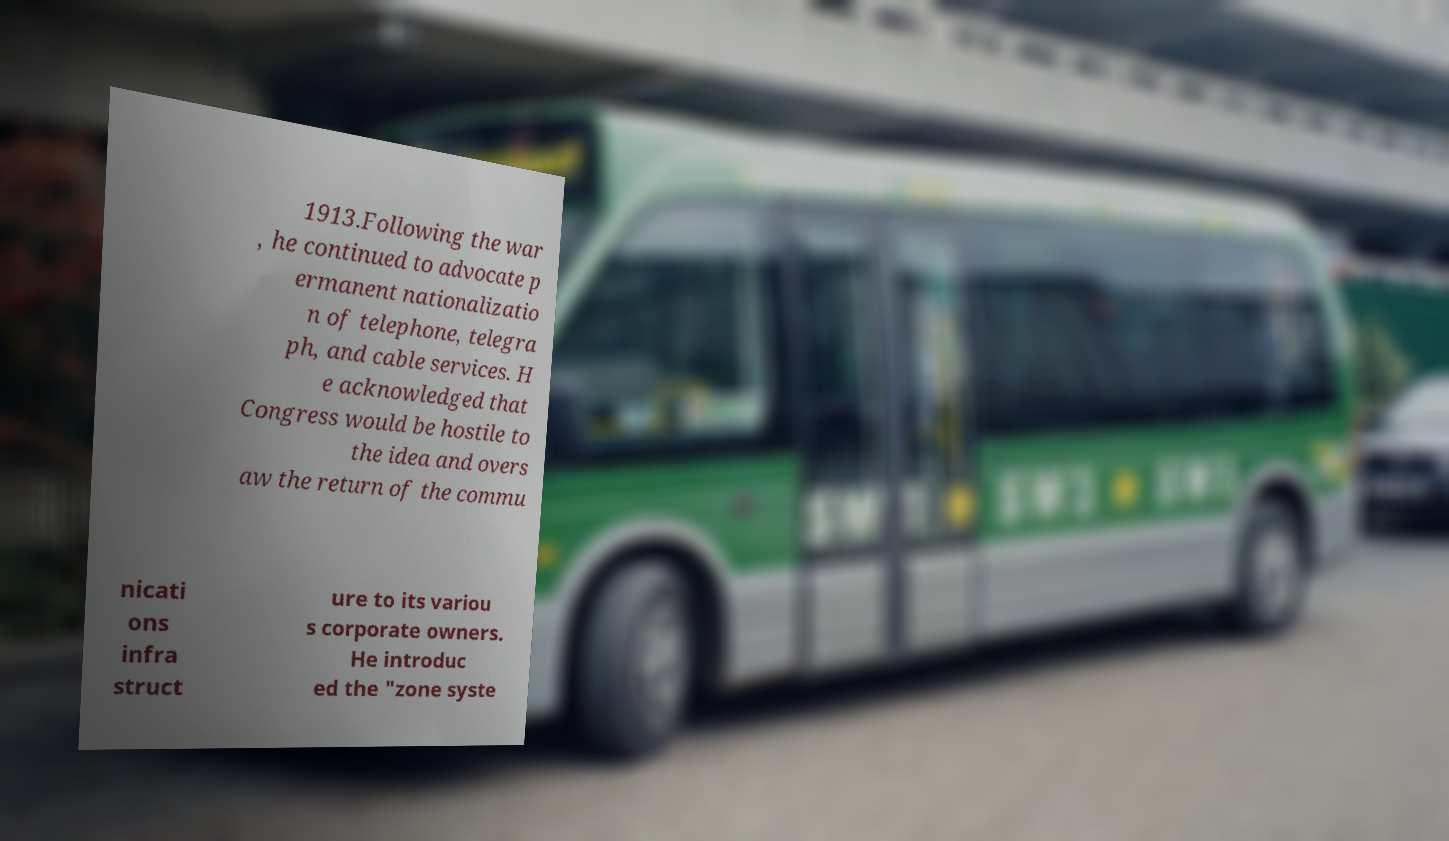There's text embedded in this image that I need extracted. Can you transcribe it verbatim? 1913.Following the war , he continued to advocate p ermanent nationalizatio n of telephone, telegra ph, and cable services. H e acknowledged that Congress would be hostile to the idea and overs aw the return of the commu nicati ons infra struct ure to its variou s corporate owners. He introduc ed the "zone syste 